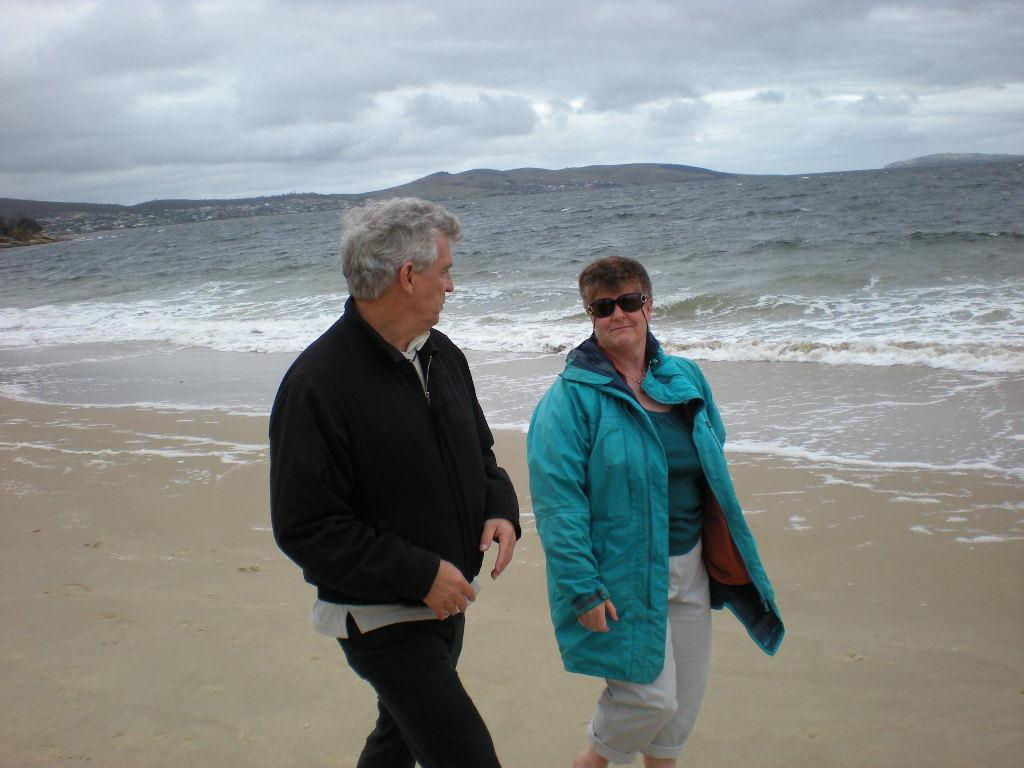What are the two persons in the image doing? The two persons in the image are walking. What type of clothing are the persons wearing? The persons are wearing coats and trousers. What can be seen in the background of the image? There is water visible in the background of the image. How would you describe the weather based on the image? The sky is cloudy in the image, suggesting a potentially overcast or rainy day. Can you see any roses blooming in the image? There are no roses visible in the image. What type of pancake is being served to the persons in the image? There is no pancake present in the image; the persons are walking and wearing coats and trousers. 